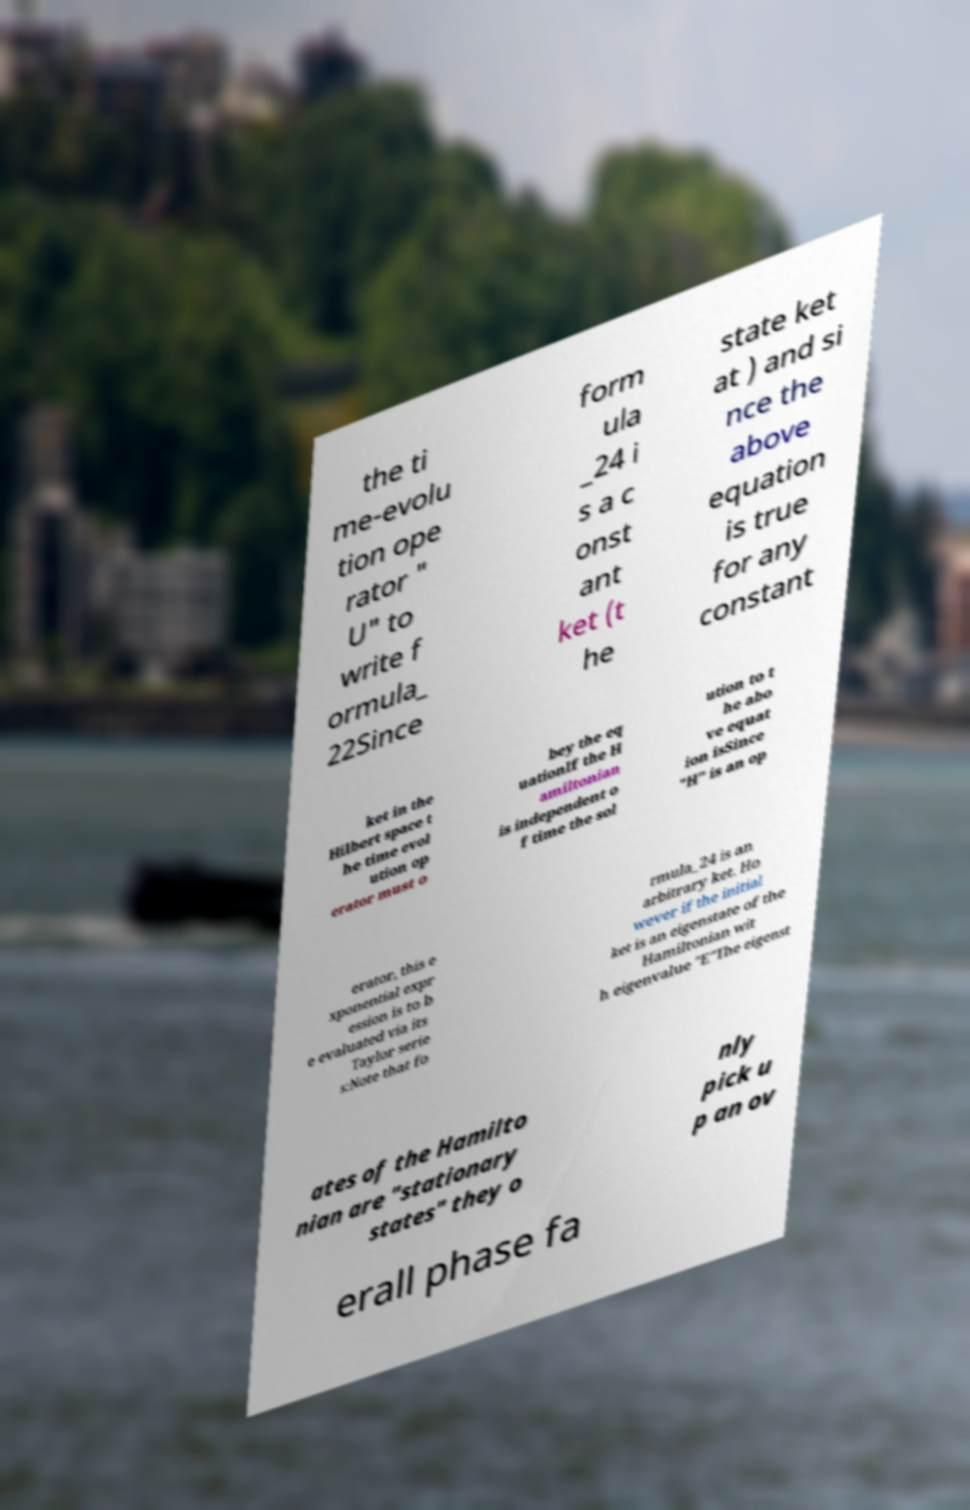I need the written content from this picture converted into text. Can you do that? the ti me-evolu tion ope rator " U" to write f ormula_ 22Since form ula _24 i s a c onst ant ket (t he state ket at ) and si nce the above equation is true for any constant ket in the Hilbert space t he time evol ution op erator must o bey the eq uationIf the H amiltonian is independent o f time the sol ution to t he abo ve equat ion isSince "H" is an op erator, this e xponential expr ession is to b e evaluated via its Taylor serie s:Note that fo rmula_24 is an arbitrary ket. Ho wever if the initial ket is an eigenstate of the Hamiltonian wit h eigenvalue "E"The eigenst ates of the Hamilto nian are "stationary states" they o nly pick u p an ov erall phase fa 